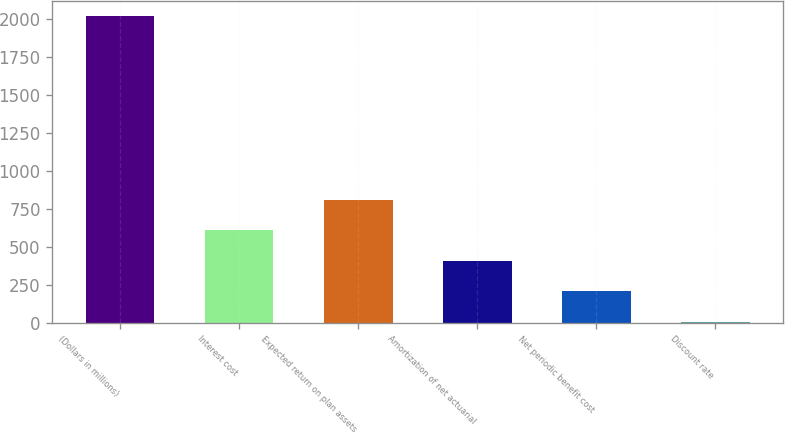Convert chart. <chart><loc_0><loc_0><loc_500><loc_500><bar_chart><fcel>(Dollars in millions)<fcel>Interest cost<fcel>Expected return on plan assets<fcel>Amortization of net actuarial<fcel>Net periodic benefit cost<fcel>Discount rate<nl><fcel>2016<fcel>607.31<fcel>808.55<fcel>406.07<fcel>204.83<fcel>3.59<nl></chart> 